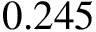<formula> <loc_0><loc_0><loc_500><loc_500>0 . 2 4 5</formula> 